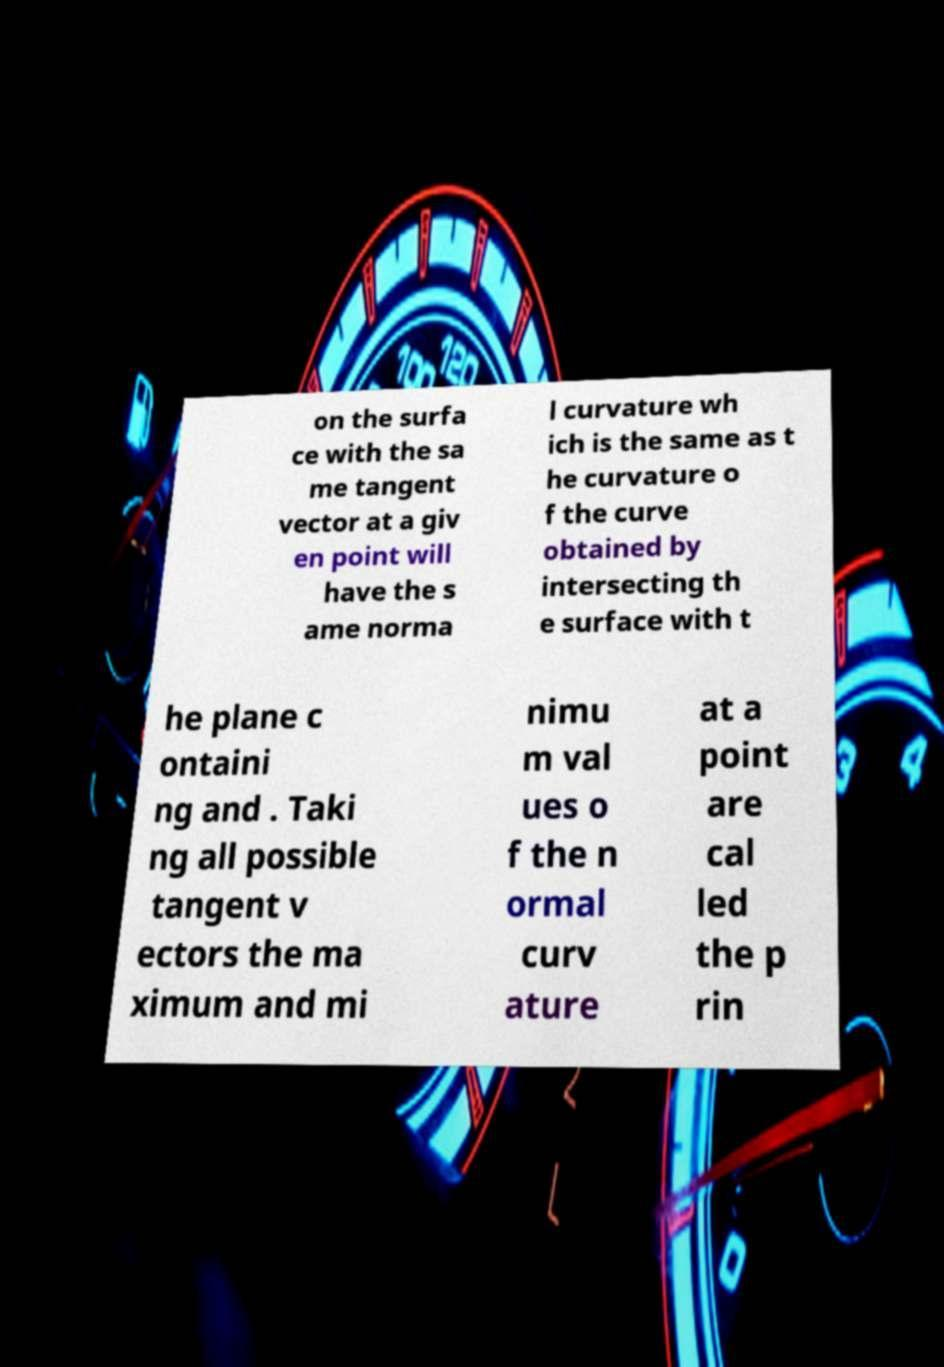There's text embedded in this image that I need extracted. Can you transcribe it verbatim? on the surfa ce with the sa me tangent vector at a giv en point will have the s ame norma l curvature wh ich is the same as t he curvature o f the curve obtained by intersecting th e surface with t he plane c ontaini ng and . Taki ng all possible tangent v ectors the ma ximum and mi nimu m val ues o f the n ormal curv ature at a point are cal led the p rin 